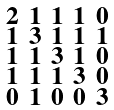<formula> <loc_0><loc_0><loc_500><loc_500>\begin{smallmatrix} 2 & 1 & 1 & 1 & 0 \\ 1 & 3 & 1 & 1 & 1 \\ 1 & 1 & 3 & 1 & 0 \\ 1 & 1 & 1 & 3 & 0 \\ 0 & 1 & 0 & 0 & 3 \end{smallmatrix}</formula> 